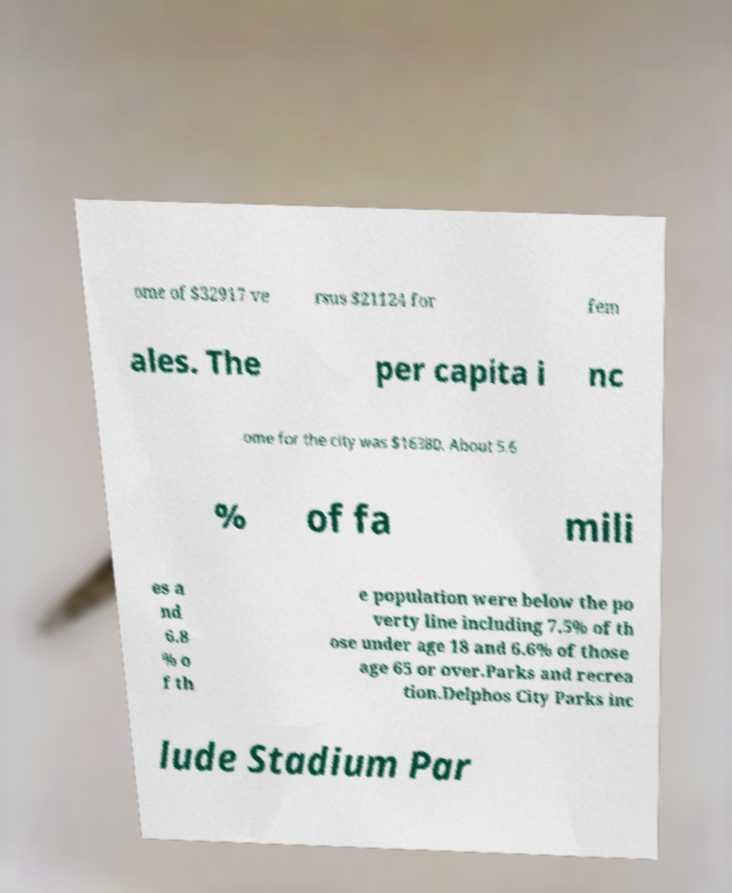Can you read and provide the text displayed in the image?This photo seems to have some interesting text. Can you extract and type it out for me? ome of $32917 ve rsus $21124 for fem ales. The per capita i nc ome for the city was $16380. About 5.6 % of fa mili es a nd 6.8 % o f th e population were below the po verty line including 7.5% of th ose under age 18 and 6.6% of those age 65 or over.Parks and recrea tion.Delphos City Parks inc lude Stadium Par 